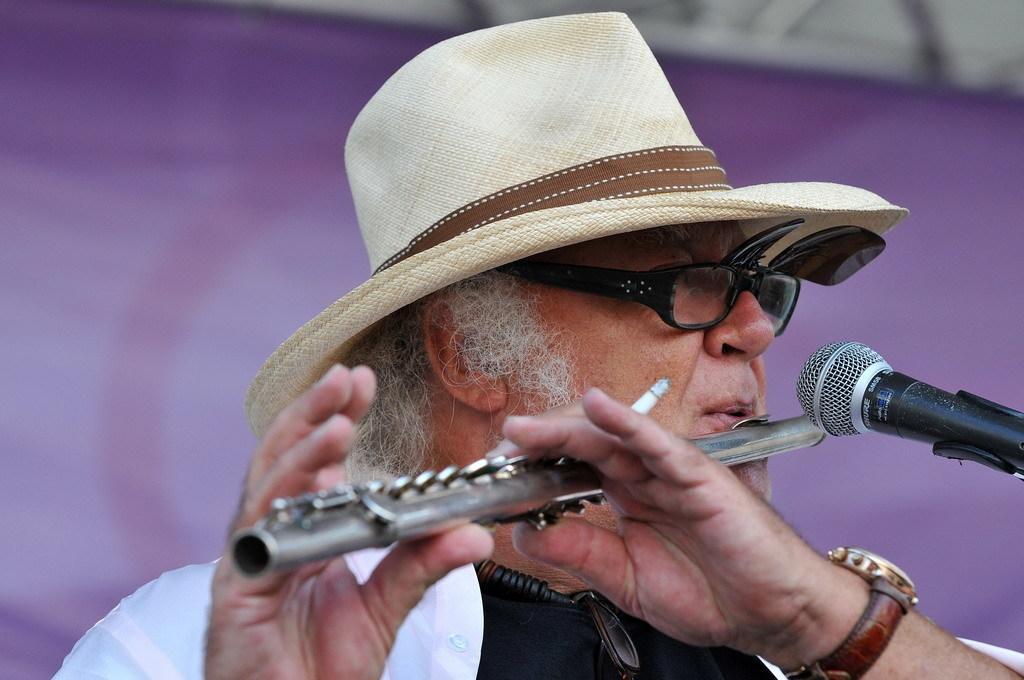Could you give a brief overview of what you see in this image? In this picture I can see there is a man standing here and he is playing a flute and he is holding a cigar in his hand and he is wearing a cap, spectacles and a watch to his left hand. 